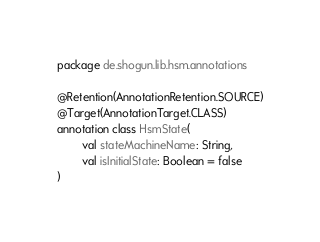<code> <loc_0><loc_0><loc_500><loc_500><_Kotlin_>package de.shogun.lib.hsm.annotations

@Retention(AnnotationRetention.SOURCE)
@Target(AnnotationTarget.CLASS)
annotation class HsmState(
        val stateMachineName: String,
        val isInitialState: Boolean = false
)</code> 